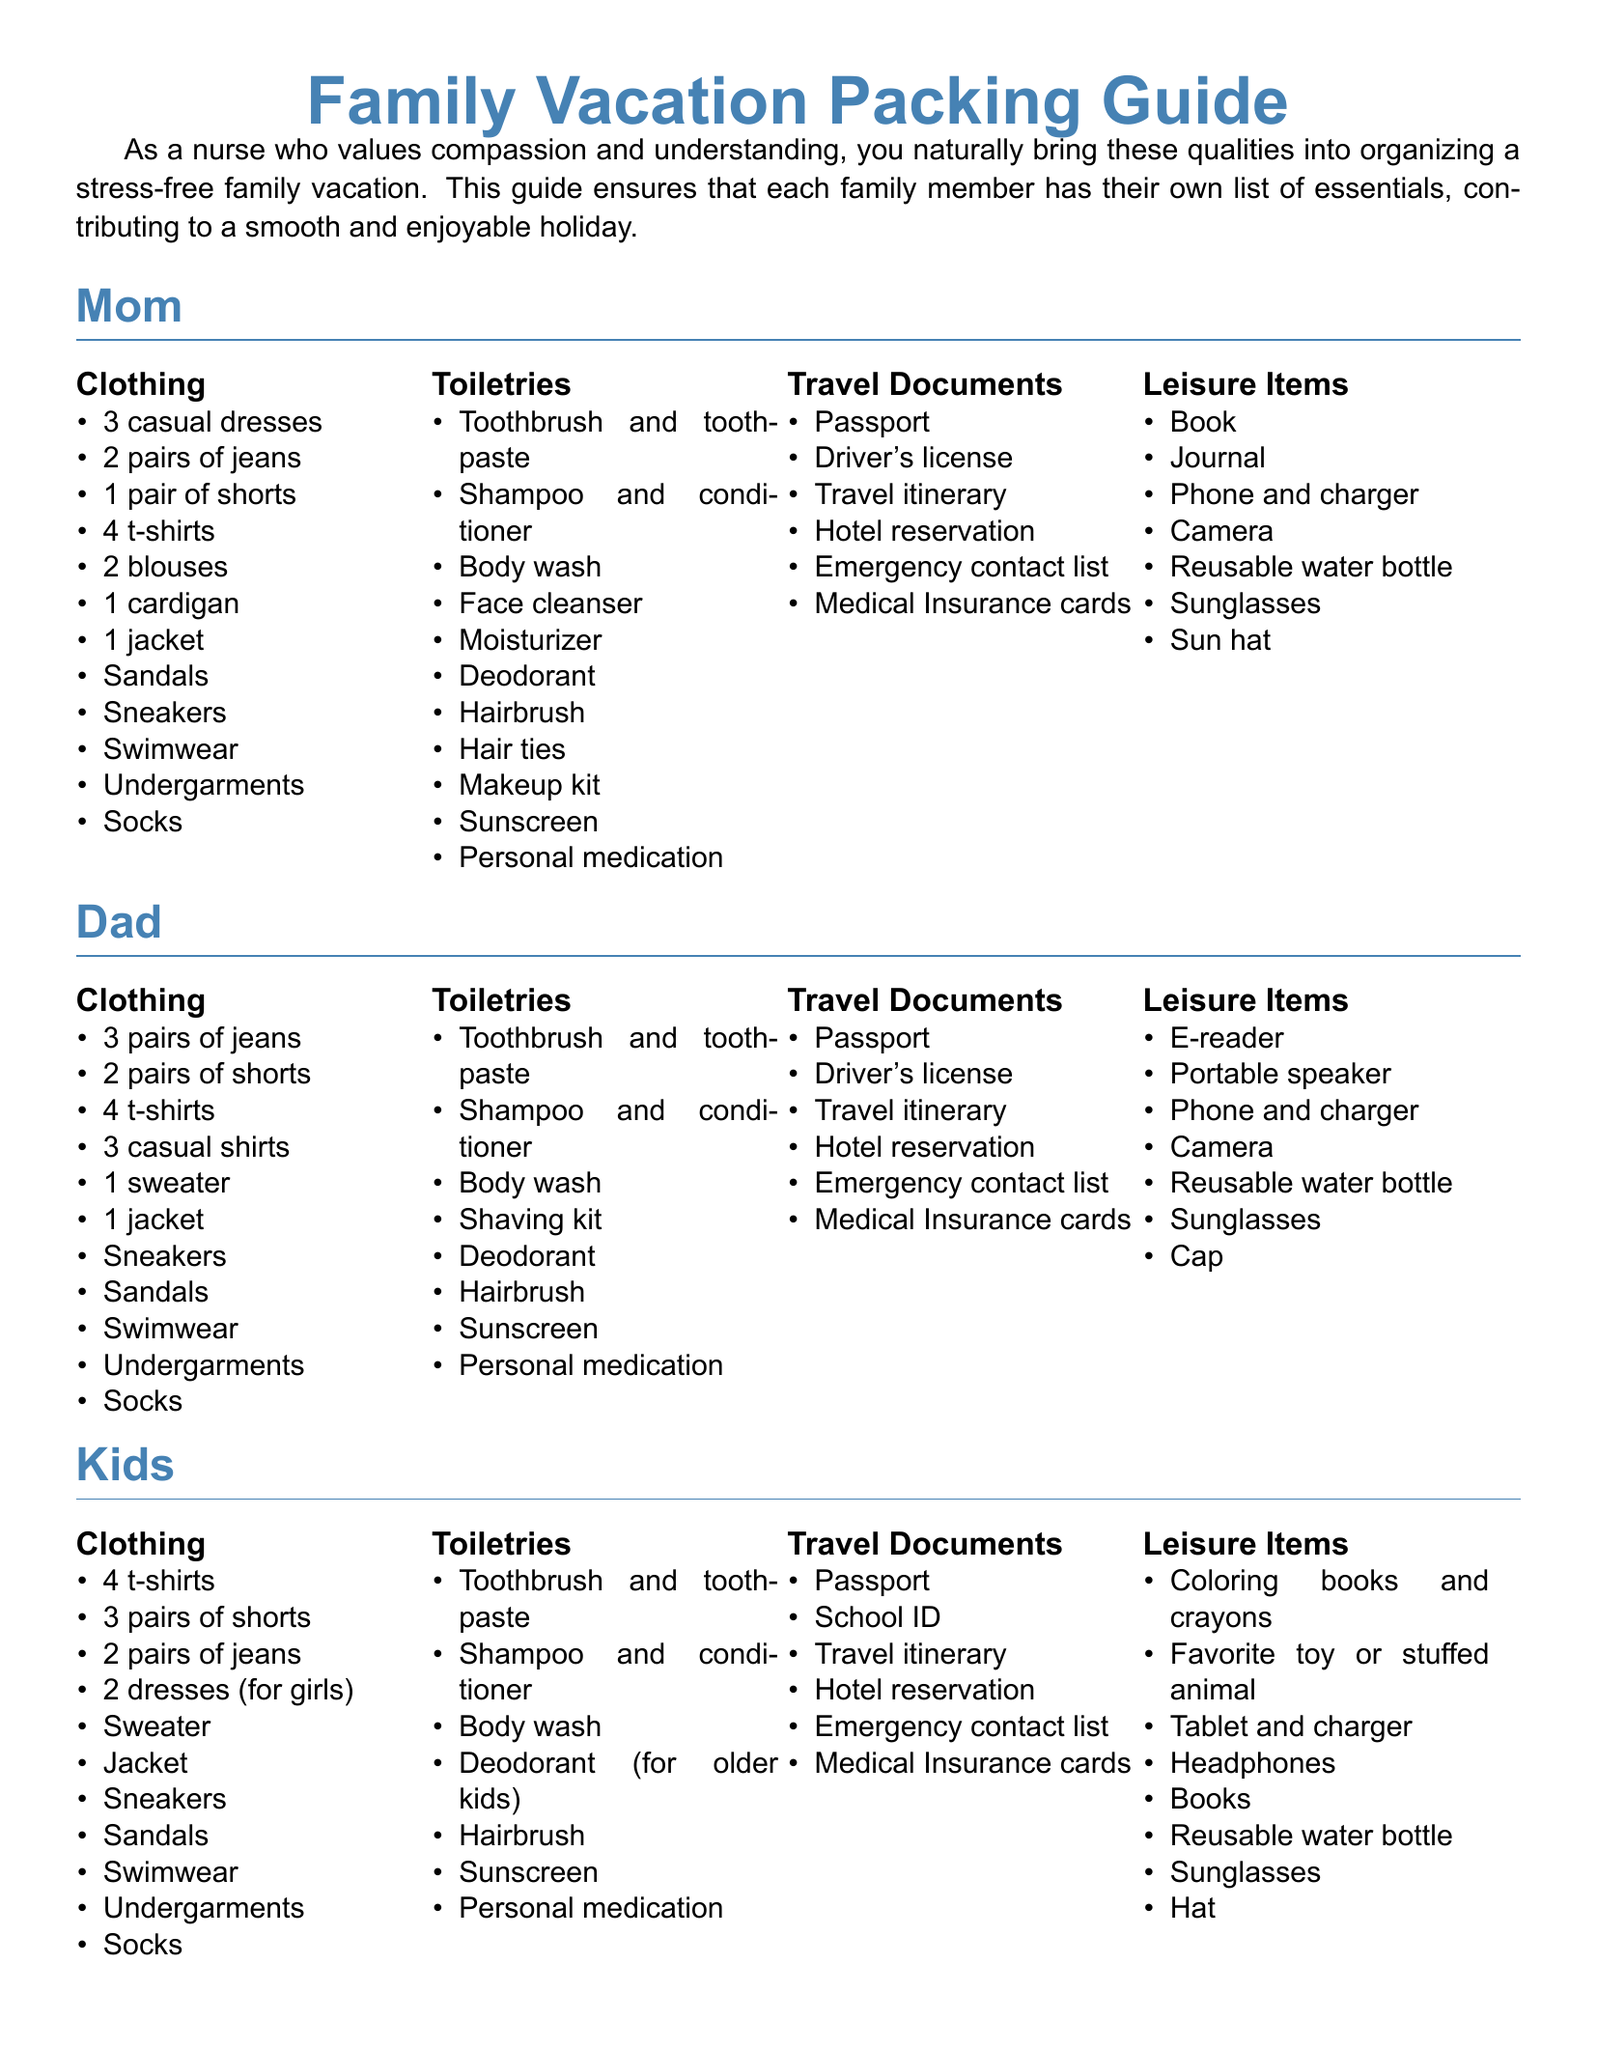What clothing items are listed for Mom? The document provides a list of clothing items specifically for Mom, including dresses, jeans, shorts, t-shirts, and more.
Answer: 3 casual dresses, 2 pairs of jeans, 1 pair of shorts, 4 t-shirts, 2 blouses, 1 cardigan, 1 jacket, Sandals, Sneakers, Swimwear, Undergarments, Socks How many leisure items does Dad have? The leisure section for Dad includes several items, which can be counted to find the total.
Answer: 7 What type of travel documents are suggested for the kids? The document outlines specific travel documents required for the kids, focusing on travel and identification needs.
Answer: Passport, School ID, Travel itinerary, Hotel reservation, Emergency contact list, Medical Insurance cards Which family member has a Shaving kit listed under toiletries? The toiletries section for each family member includes various specific items, identifying who has the shaving kit.
Answer: Dad How many pairs of shorts are recommended for kids? By reviewing the clothing list for kids, we can determine how many pairs of shorts are suggested.
Answer: 3 pairs of shorts What is the main purpose of this document? The document aims to organize a stress-free family vacation by providing packing guides for each family member.
Answer: Stress-free family vacation What item does Mom need for sun protection? The toiletries section includes specific items related to sun protection that Mom should pack.
Answer: Sunscreen 